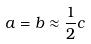Convert formula to latex. <formula><loc_0><loc_0><loc_500><loc_500>a = b \approx \frac { 1 } { 2 } c</formula> 